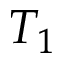Convert formula to latex. <formula><loc_0><loc_0><loc_500><loc_500>T _ { 1 }</formula> 